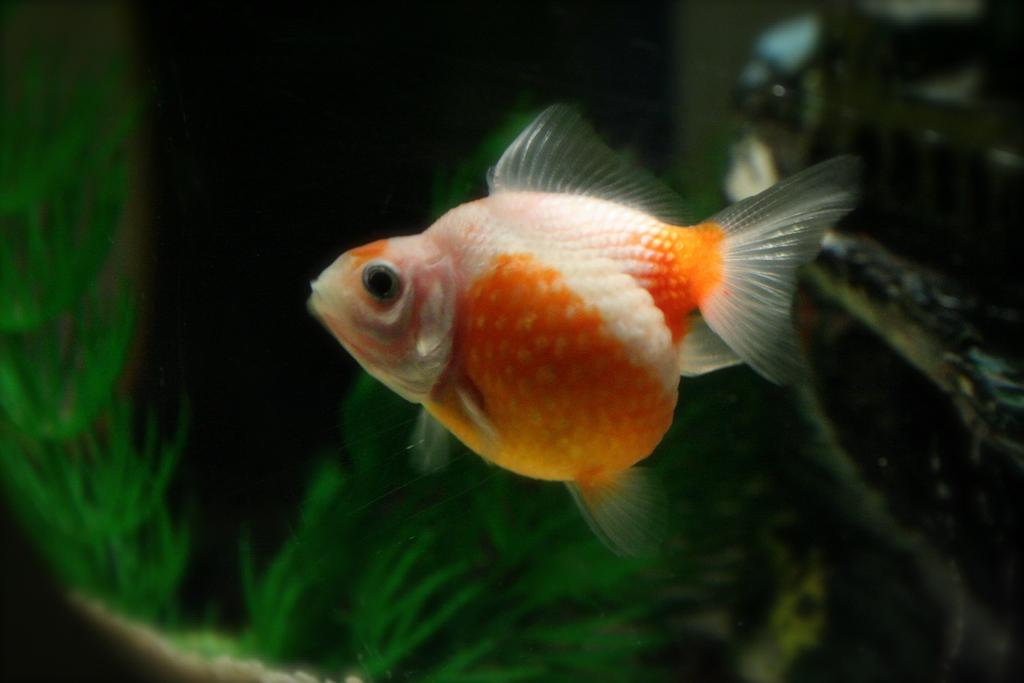What type of animal is in the image? There is a fish in the image. What colors can be seen on the fish? The fish has orange and white colors. How would you describe the background of the image? The background portion of the image is blurry. What type of vegetation is visible in the image? There is grass visible in the image. What year is depicted in the image? The image does not depict a specific year; it is a photograph of a fish and grass. 